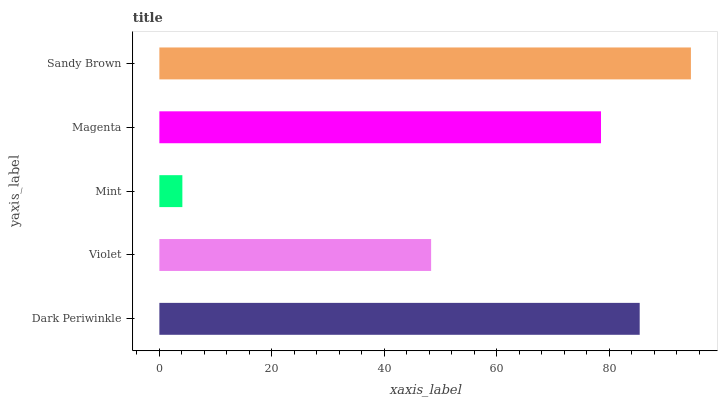Is Mint the minimum?
Answer yes or no. Yes. Is Sandy Brown the maximum?
Answer yes or no. Yes. Is Violet the minimum?
Answer yes or no. No. Is Violet the maximum?
Answer yes or no. No. Is Dark Periwinkle greater than Violet?
Answer yes or no. Yes. Is Violet less than Dark Periwinkle?
Answer yes or no. Yes. Is Violet greater than Dark Periwinkle?
Answer yes or no. No. Is Dark Periwinkle less than Violet?
Answer yes or no. No. Is Magenta the high median?
Answer yes or no. Yes. Is Magenta the low median?
Answer yes or no. Yes. Is Sandy Brown the high median?
Answer yes or no. No. Is Violet the low median?
Answer yes or no. No. 